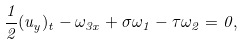<formula> <loc_0><loc_0><loc_500><loc_500>\frac { 1 } { 2 } ( u _ { y } ) _ { t } - \omega _ { 3 x } + \sigma \omega _ { 1 } - \tau \omega _ { 2 } = 0 ,</formula> 